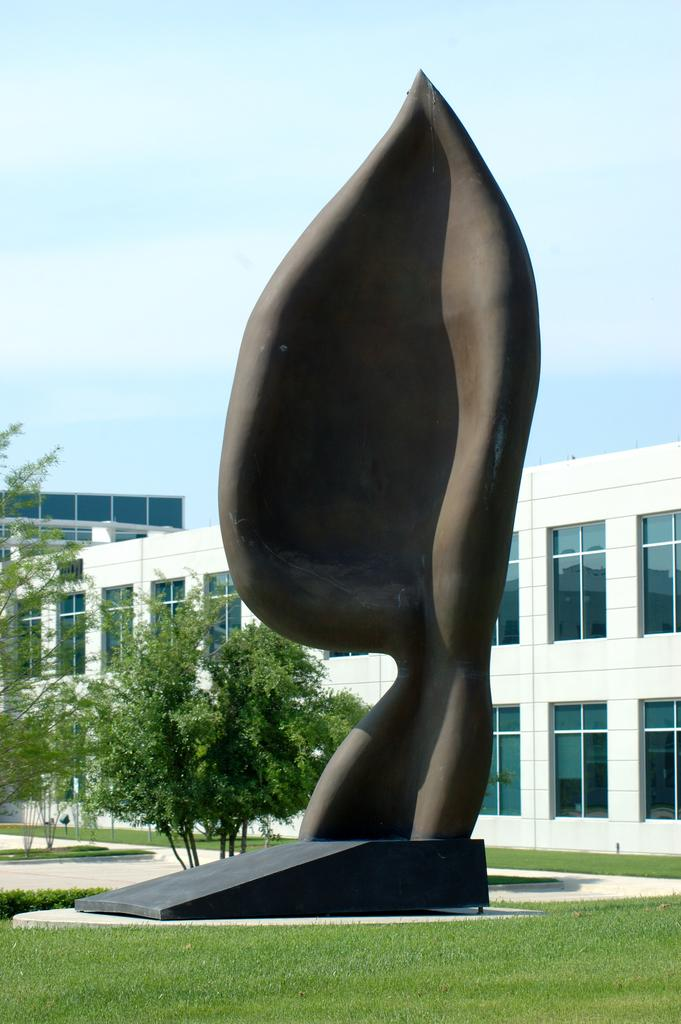What is the main subject in the foreground of the image? There is a sculpture in the foreground of the image. What type of vegetation surrounds the sculpture? There is grass around the sculpture. What can be seen in the background of the image? There are trees, a building, and the sky visible in the background of the image. Can you describe the sky in the image? The sky is visible in the background of the image, and there is a cloud present. What type of lunch is being served in the image? There is no lunch present in the image; it features a sculpture surrounded by grass, with trees, a building, and the sky visible in the background. What type of stem can be seen growing from the sculpture in the image? There is no stem growing from the sculpture in the image. 